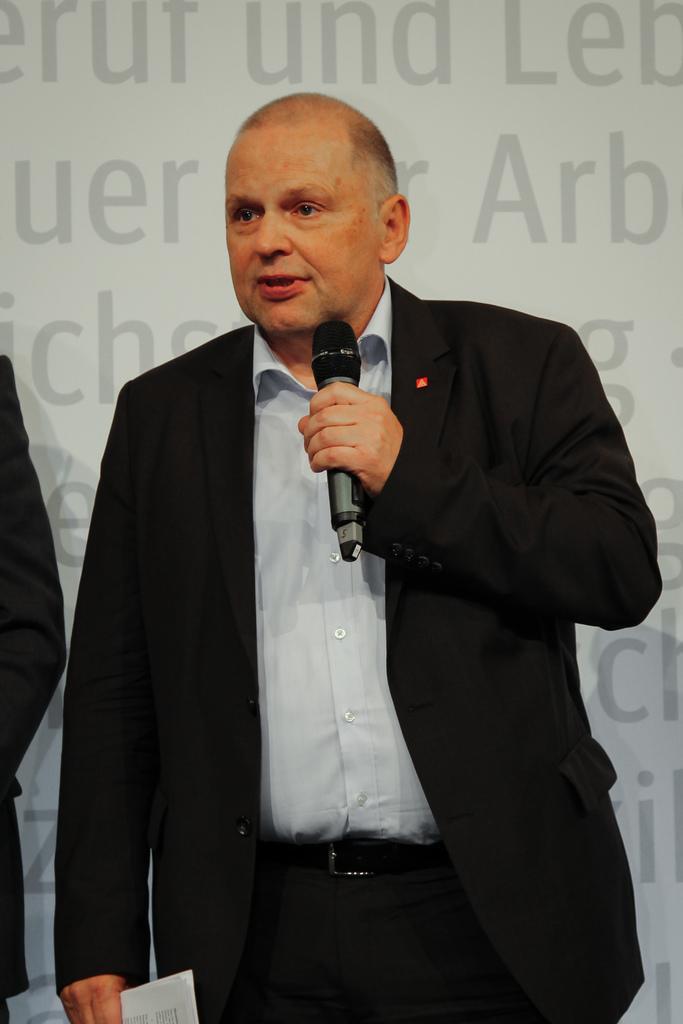How would you summarize this image in a sentence or two? This picture shows a man standing and holding a mic in his hand. And in the background there is a wall. 